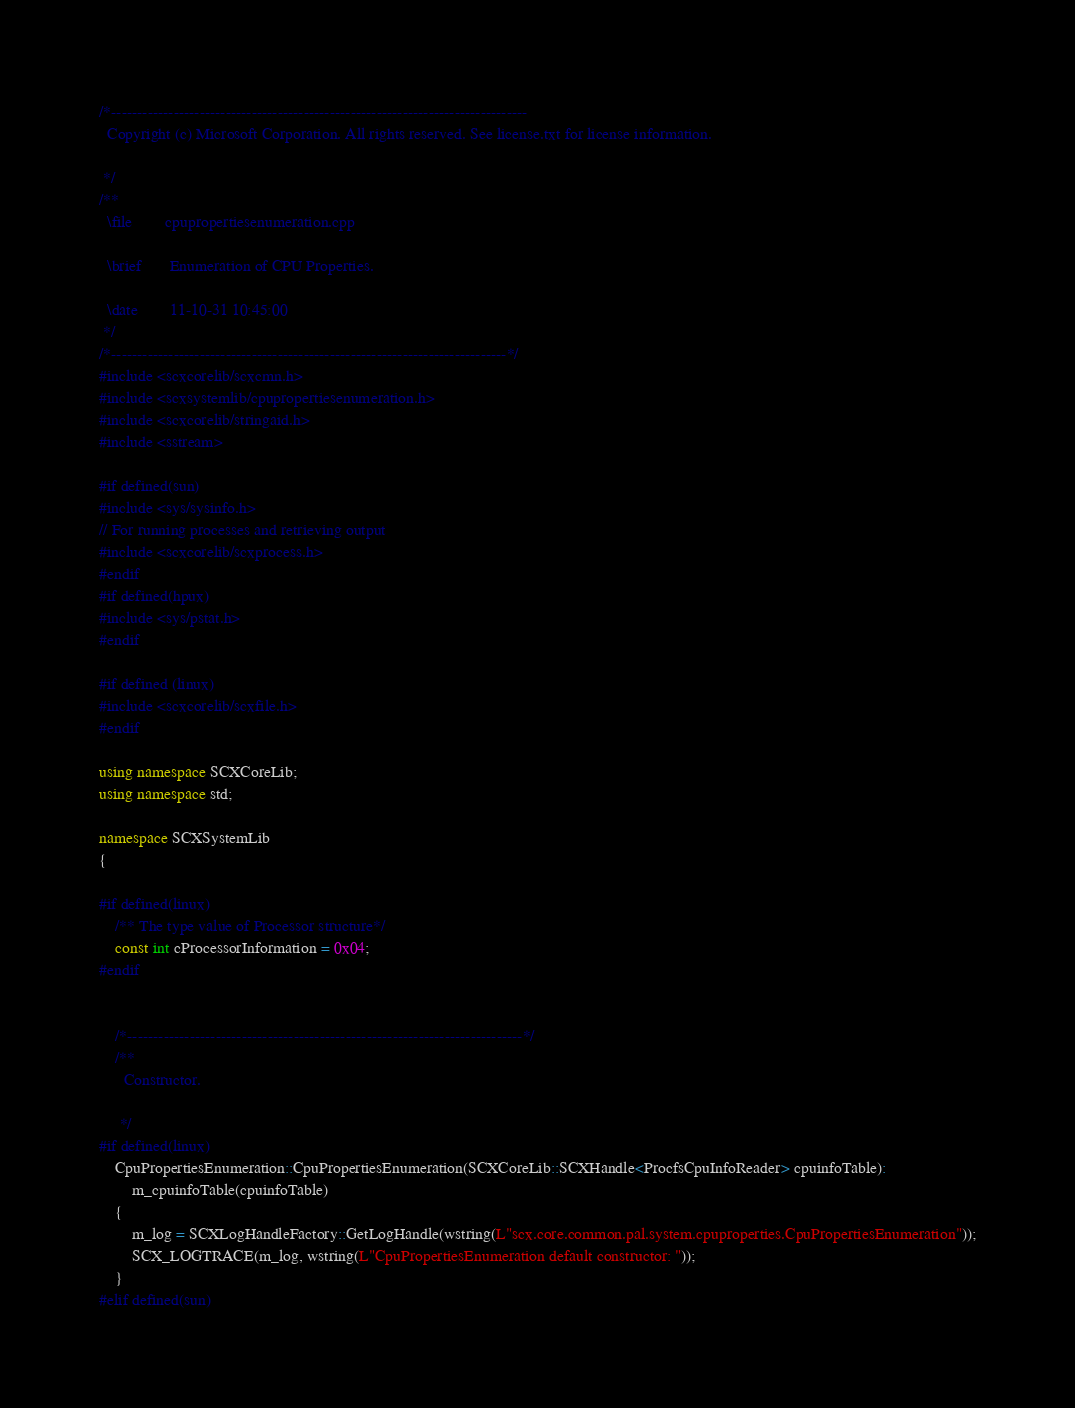Convert code to text. <code><loc_0><loc_0><loc_500><loc_500><_C++_>/*--------------------------------------------------------------------------------
  Copyright (c) Microsoft Corporation. All rights reserved. See license.txt for license information.

 */
/**
  \file        cpupropertiesenumeration.cpp

  \brief       Enumeration of CPU Properties. 

  \date        11-10-31 10:45:00
 */
/*----------------------------------------------------------------------------*/
#include <scxcorelib/scxcmn.h>
#include <scxsystemlib/cpupropertiesenumeration.h>
#include <scxcorelib/stringaid.h>
#include <sstream>

#if defined(sun)
#include <sys/sysinfo.h>
// For running processes and retrieving output
#include <scxcorelib/scxprocess.h>
#endif
#if defined(hpux)
#include <sys/pstat.h>
#endif

#if defined (linux)
#include <scxcorelib/scxfile.h>
#endif

using namespace SCXCoreLib;
using namespace std;

namespace SCXSystemLib
{

#if defined(linux) 
    /** The type value of Processor structure*/ 
    const int cProcessorInformation = 0x04;
#endif


    /*----------------------------------------------------------------------------*/
    /**
      Constructor. 

     */
#if defined(linux) 
    CpuPropertiesEnumeration::CpuPropertiesEnumeration(SCXCoreLib::SCXHandle<ProcfsCpuInfoReader> cpuinfoTable):
        m_cpuinfoTable(cpuinfoTable)
    {
        m_log = SCXLogHandleFactory::GetLogHandle(wstring(L"scx.core.common.pal.system.cpuproperties.CpuPropertiesEnumeration"));
        SCX_LOGTRACE(m_log, wstring(L"CpuPropertiesEnumeration default constructor: "));
    }
#elif defined(sun) </code> 